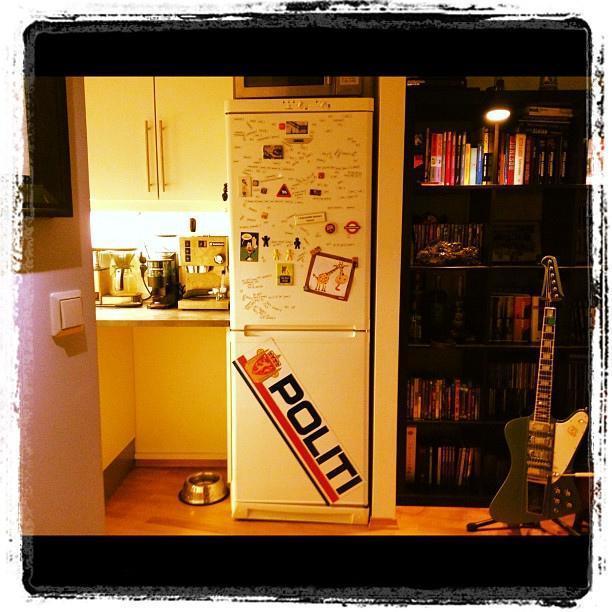How many books are in the picture?
Give a very brief answer. 3. 